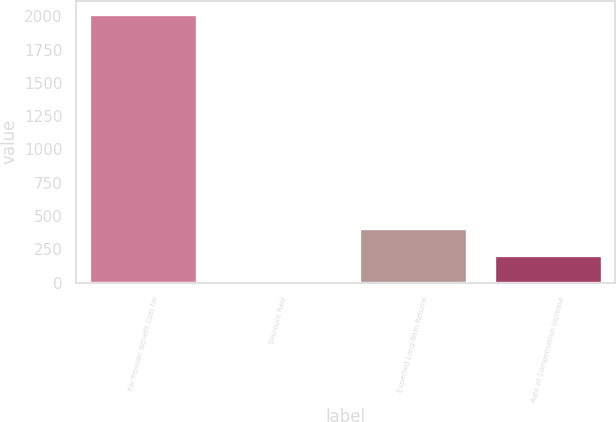Convert chart to OTSL. <chart><loc_0><loc_0><loc_500><loc_500><bar_chart><fcel>For Periodic Benefit Cost for<fcel>Discount Rate<fcel>Expected Long-Term Returns<fcel>Rate of Compensation Increase<nl><fcel>2017<fcel>4.27<fcel>406.81<fcel>205.54<nl></chart> 